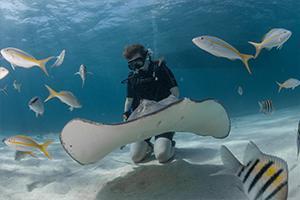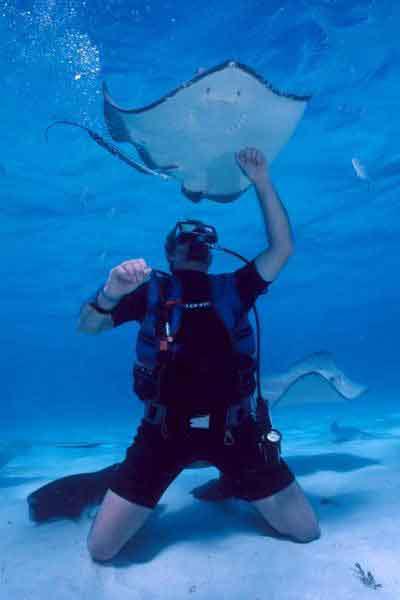The first image is the image on the left, the second image is the image on the right. For the images displayed, is the sentence "There are exactly two scuba divers." factually correct? Answer yes or no. Yes. The first image is the image on the left, the second image is the image on the right. For the images shown, is this caption "There is at least one image of a sting ray over the sand that is in front of a diver who is swimming." true? Answer yes or no. No. 